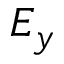Convert formula to latex. <formula><loc_0><loc_0><loc_500><loc_500>E _ { y }</formula> 